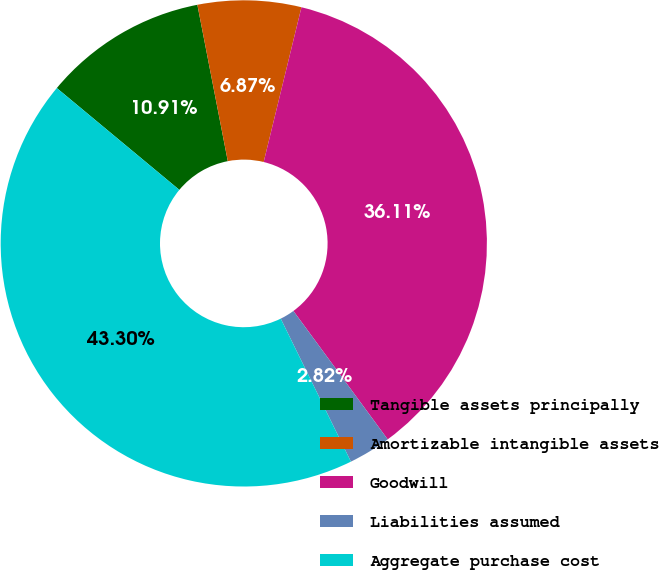Convert chart. <chart><loc_0><loc_0><loc_500><loc_500><pie_chart><fcel>Tangible assets principally<fcel>Amortizable intangible assets<fcel>Goodwill<fcel>Liabilities assumed<fcel>Aggregate purchase cost<nl><fcel>10.91%<fcel>6.87%<fcel>36.11%<fcel>2.82%<fcel>43.3%<nl></chart> 